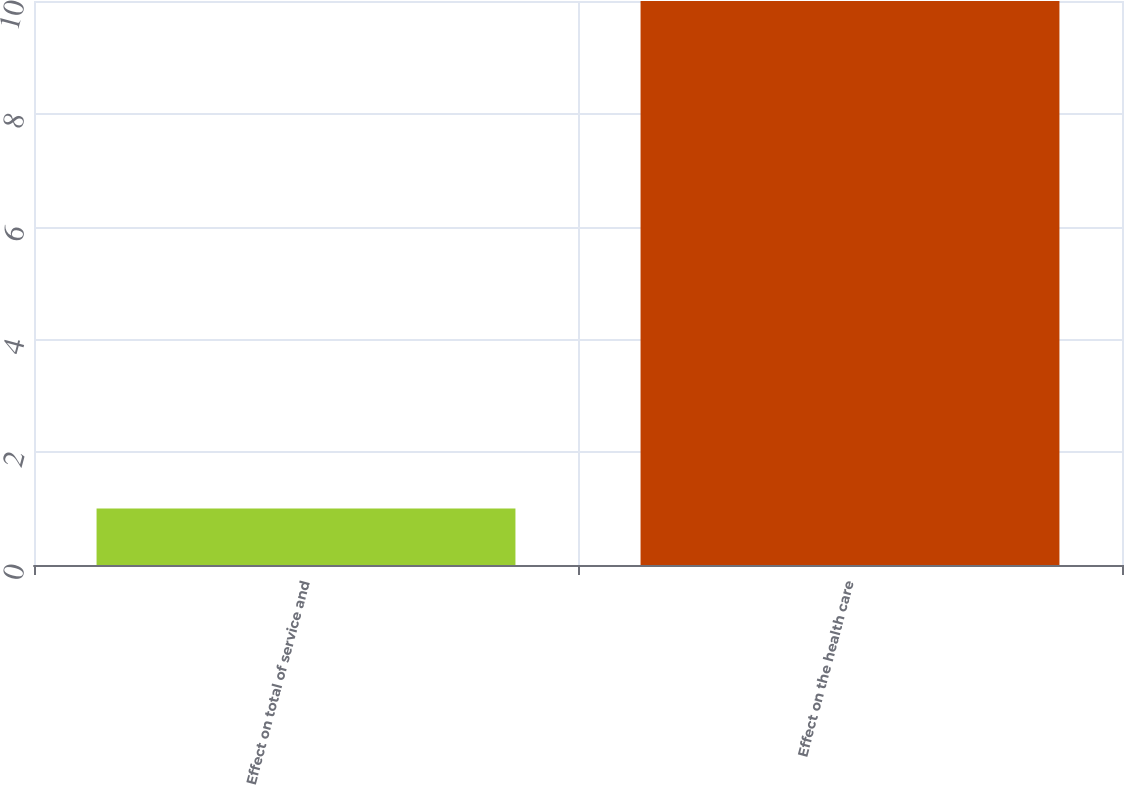Convert chart. <chart><loc_0><loc_0><loc_500><loc_500><bar_chart><fcel>Effect on total of service and<fcel>Effect on the health care<nl><fcel>1<fcel>10<nl></chart> 